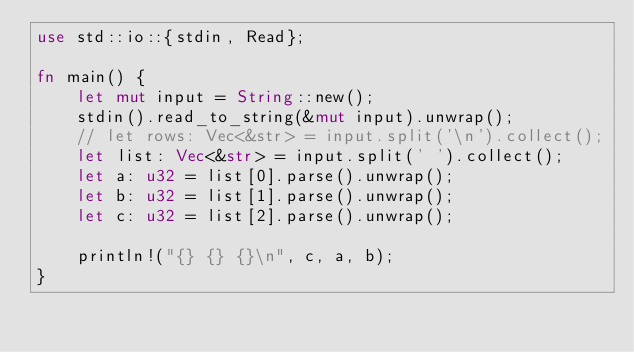<code> <loc_0><loc_0><loc_500><loc_500><_Rust_>use std::io::{stdin, Read};

fn main() {
    let mut input = String::new();
    stdin().read_to_string(&mut input).unwrap();
    // let rows: Vec<&str> = input.split('\n').collect();
    let list: Vec<&str> = input.split(' ').collect();
    let a: u32 = list[0].parse().unwrap();
    let b: u32 = list[1].parse().unwrap();
    let c: u32 = list[2].parse().unwrap();
    
    println!("{} {} {}\n", c, a, b);
}</code> 